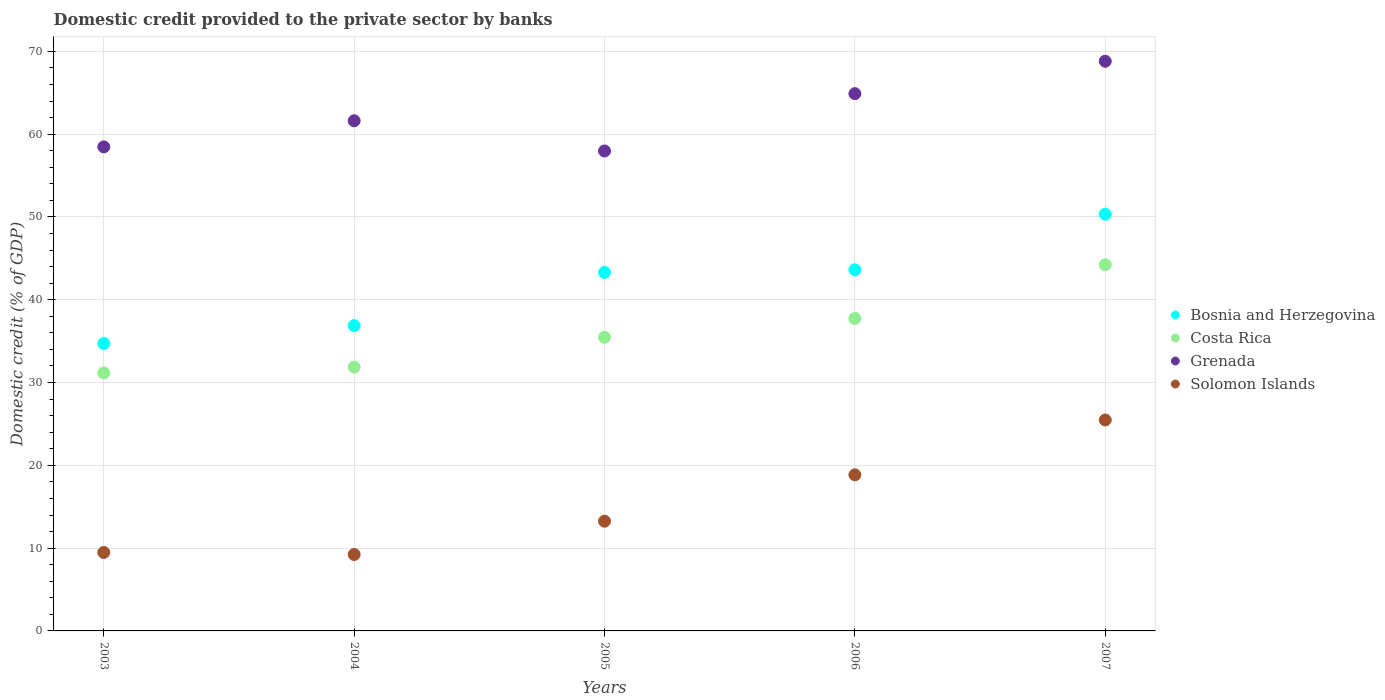How many different coloured dotlines are there?
Offer a terse response. 4. Is the number of dotlines equal to the number of legend labels?
Offer a terse response. Yes. What is the domestic credit provided to the private sector by banks in Costa Rica in 2003?
Give a very brief answer. 31.15. Across all years, what is the maximum domestic credit provided to the private sector by banks in Grenada?
Your answer should be compact. 68.81. Across all years, what is the minimum domestic credit provided to the private sector by banks in Solomon Islands?
Make the answer very short. 9.23. In which year was the domestic credit provided to the private sector by banks in Grenada maximum?
Your answer should be compact. 2007. What is the total domestic credit provided to the private sector by banks in Bosnia and Herzegovina in the graph?
Provide a succinct answer. 208.86. What is the difference between the domestic credit provided to the private sector by banks in Costa Rica in 2004 and that in 2006?
Ensure brevity in your answer.  -5.88. What is the difference between the domestic credit provided to the private sector by banks in Grenada in 2004 and the domestic credit provided to the private sector by banks in Costa Rica in 2005?
Make the answer very short. 26.14. What is the average domestic credit provided to the private sector by banks in Solomon Islands per year?
Provide a short and direct response. 15.26. In the year 2007, what is the difference between the domestic credit provided to the private sector by banks in Bosnia and Herzegovina and domestic credit provided to the private sector by banks in Costa Rica?
Provide a short and direct response. 6.12. What is the ratio of the domestic credit provided to the private sector by banks in Costa Rica in 2003 to that in 2007?
Your answer should be compact. 0.7. Is the domestic credit provided to the private sector by banks in Grenada in 2006 less than that in 2007?
Ensure brevity in your answer.  Yes. Is the difference between the domestic credit provided to the private sector by banks in Bosnia and Herzegovina in 2006 and 2007 greater than the difference between the domestic credit provided to the private sector by banks in Costa Rica in 2006 and 2007?
Your answer should be compact. No. What is the difference between the highest and the second highest domestic credit provided to the private sector by banks in Bosnia and Herzegovina?
Offer a terse response. 6.72. What is the difference between the highest and the lowest domestic credit provided to the private sector by banks in Grenada?
Provide a short and direct response. 10.84. Is it the case that in every year, the sum of the domestic credit provided to the private sector by banks in Costa Rica and domestic credit provided to the private sector by banks in Solomon Islands  is greater than the sum of domestic credit provided to the private sector by banks in Grenada and domestic credit provided to the private sector by banks in Bosnia and Herzegovina?
Your answer should be very brief. No. How many years are there in the graph?
Make the answer very short. 5. Are the values on the major ticks of Y-axis written in scientific E-notation?
Make the answer very short. No. Does the graph contain any zero values?
Your answer should be compact. No. What is the title of the graph?
Your response must be concise. Domestic credit provided to the private sector by banks. What is the label or title of the X-axis?
Provide a succinct answer. Years. What is the label or title of the Y-axis?
Offer a terse response. Domestic credit (% of GDP). What is the Domestic credit (% of GDP) in Bosnia and Herzegovina in 2003?
Keep it short and to the point. 34.72. What is the Domestic credit (% of GDP) in Costa Rica in 2003?
Your answer should be very brief. 31.15. What is the Domestic credit (% of GDP) in Grenada in 2003?
Keep it short and to the point. 58.46. What is the Domestic credit (% of GDP) in Solomon Islands in 2003?
Make the answer very short. 9.48. What is the Domestic credit (% of GDP) of Bosnia and Herzegovina in 2004?
Your answer should be very brief. 36.88. What is the Domestic credit (% of GDP) of Costa Rica in 2004?
Your answer should be very brief. 31.87. What is the Domestic credit (% of GDP) in Grenada in 2004?
Your response must be concise. 61.62. What is the Domestic credit (% of GDP) in Solomon Islands in 2004?
Your answer should be very brief. 9.23. What is the Domestic credit (% of GDP) of Bosnia and Herzegovina in 2005?
Provide a short and direct response. 43.31. What is the Domestic credit (% of GDP) in Costa Rica in 2005?
Make the answer very short. 35.48. What is the Domestic credit (% of GDP) in Grenada in 2005?
Make the answer very short. 57.97. What is the Domestic credit (% of GDP) of Solomon Islands in 2005?
Make the answer very short. 13.25. What is the Domestic credit (% of GDP) in Bosnia and Herzegovina in 2006?
Offer a terse response. 43.62. What is the Domestic credit (% of GDP) of Costa Rica in 2006?
Ensure brevity in your answer.  37.75. What is the Domestic credit (% of GDP) in Grenada in 2006?
Provide a succinct answer. 64.89. What is the Domestic credit (% of GDP) in Solomon Islands in 2006?
Your answer should be very brief. 18.85. What is the Domestic credit (% of GDP) of Bosnia and Herzegovina in 2007?
Provide a succinct answer. 50.34. What is the Domestic credit (% of GDP) in Costa Rica in 2007?
Your response must be concise. 44.22. What is the Domestic credit (% of GDP) in Grenada in 2007?
Offer a terse response. 68.81. What is the Domestic credit (% of GDP) of Solomon Islands in 2007?
Ensure brevity in your answer.  25.48. Across all years, what is the maximum Domestic credit (% of GDP) of Bosnia and Herzegovina?
Give a very brief answer. 50.34. Across all years, what is the maximum Domestic credit (% of GDP) of Costa Rica?
Provide a short and direct response. 44.22. Across all years, what is the maximum Domestic credit (% of GDP) in Grenada?
Make the answer very short. 68.81. Across all years, what is the maximum Domestic credit (% of GDP) in Solomon Islands?
Offer a very short reply. 25.48. Across all years, what is the minimum Domestic credit (% of GDP) in Bosnia and Herzegovina?
Provide a succinct answer. 34.72. Across all years, what is the minimum Domestic credit (% of GDP) of Costa Rica?
Provide a short and direct response. 31.15. Across all years, what is the minimum Domestic credit (% of GDP) in Grenada?
Your response must be concise. 57.97. Across all years, what is the minimum Domestic credit (% of GDP) in Solomon Islands?
Keep it short and to the point. 9.23. What is the total Domestic credit (% of GDP) of Bosnia and Herzegovina in the graph?
Offer a very short reply. 208.86. What is the total Domestic credit (% of GDP) in Costa Rica in the graph?
Make the answer very short. 180.46. What is the total Domestic credit (% of GDP) in Grenada in the graph?
Offer a terse response. 311.75. What is the total Domestic credit (% of GDP) of Solomon Islands in the graph?
Provide a succinct answer. 76.29. What is the difference between the Domestic credit (% of GDP) of Bosnia and Herzegovina in 2003 and that in 2004?
Offer a very short reply. -2.16. What is the difference between the Domestic credit (% of GDP) of Costa Rica in 2003 and that in 2004?
Your response must be concise. -0.72. What is the difference between the Domestic credit (% of GDP) in Grenada in 2003 and that in 2004?
Your answer should be very brief. -3.15. What is the difference between the Domestic credit (% of GDP) in Solomon Islands in 2003 and that in 2004?
Make the answer very short. 0.25. What is the difference between the Domestic credit (% of GDP) in Bosnia and Herzegovina in 2003 and that in 2005?
Keep it short and to the point. -8.59. What is the difference between the Domestic credit (% of GDP) in Costa Rica in 2003 and that in 2005?
Your answer should be very brief. -4.33. What is the difference between the Domestic credit (% of GDP) in Grenada in 2003 and that in 2005?
Give a very brief answer. 0.5. What is the difference between the Domestic credit (% of GDP) of Solomon Islands in 2003 and that in 2005?
Your response must be concise. -3.78. What is the difference between the Domestic credit (% of GDP) in Bosnia and Herzegovina in 2003 and that in 2006?
Provide a succinct answer. -8.9. What is the difference between the Domestic credit (% of GDP) of Costa Rica in 2003 and that in 2006?
Your answer should be compact. -6.6. What is the difference between the Domestic credit (% of GDP) of Grenada in 2003 and that in 2006?
Keep it short and to the point. -6.43. What is the difference between the Domestic credit (% of GDP) of Solomon Islands in 2003 and that in 2006?
Provide a short and direct response. -9.37. What is the difference between the Domestic credit (% of GDP) in Bosnia and Herzegovina in 2003 and that in 2007?
Give a very brief answer. -15.62. What is the difference between the Domestic credit (% of GDP) of Costa Rica in 2003 and that in 2007?
Keep it short and to the point. -13.07. What is the difference between the Domestic credit (% of GDP) of Grenada in 2003 and that in 2007?
Offer a terse response. -10.34. What is the difference between the Domestic credit (% of GDP) of Solomon Islands in 2003 and that in 2007?
Give a very brief answer. -16. What is the difference between the Domestic credit (% of GDP) of Bosnia and Herzegovina in 2004 and that in 2005?
Give a very brief answer. -6.43. What is the difference between the Domestic credit (% of GDP) of Costa Rica in 2004 and that in 2005?
Offer a terse response. -3.61. What is the difference between the Domestic credit (% of GDP) in Grenada in 2004 and that in 2005?
Give a very brief answer. 3.65. What is the difference between the Domestic credit (% of GDP) in Solomon Islands in 2004 and that in 2005?
Your answer should be very brief. -4.02. What is the difference between the Domestic credit (% of GDP) of Bosnia and Herzegovina in 2004 and that in 2006?
Your answer should be very brief. -6.74. What is the difference between the Domestic credit (% of GDP) of Costa Rica in 2004 and that in 2006?
Your response must be concise. -5.88. What is the difference between the Domestic credit (% of GDP) in Grenada in 2004 and that in 2006?
Provide a succinct answer. -3.28. What is the difference between the Domestic credit (% of GDP) of Solomon Islands in 2004 and that in 2006?
Your response must be concise. -9.62. What is the difference between the Domestic credit (% of GDP) of Bosnia and Herzegovina in 2004 and that in 2007?
Your answer should be compact. -13.46. What is the difference between the Domestic credit (% of GDP) of Costa Rica in 2004 and that in 2007?
Your response must be concise. -12.35. What is the difference between the Domestic credit (% of GDP) in Grenada in 2004 and that in 2007?
Keep it short and to the point. -7.19. What is the difference between the Domestic credit (% of GDP) in Solomon Islands in 2004 and that in 2007?
Your answer should be very brief. -16.25. What is the difference between the Domestic credit (% of GDP) in Bosnia and Herzegovina in 2005 and that in 2006?
Ensure brevity in your answer.  -0.31. What is the difference between the Domestic credit (% of GDP) of Costa Rica in 2005 and that in 2006?
Your answer should be very brief. -2.27. What is the difference between the Domestic credit (% of GDP) in Grenada in 2005 and that in 2006?
Your response must be concise. -6.93. What is the difference between the Domestic credit (% of GDP) in Solomon Islands in 2005 and that in 2006?
Your answer should be compact. -5.6. What is the difference between the Domestic credit (% of GDP) of Bosnia and Herzegovina in 2005 and that in 2007?
Your answer should be very brief. -7.03. What is the difference between the Domestic credit (% of GDP) of Costa Rica in 2005 and that in 2007?
Offer a terse response. -8.74. What is the difference between the Domestic credit (% of GDP) of Grenada in 2005 and that in 2007?
Your response must be concise. -10.84. What is the difference between the Domestic credit (% of GDP) in Solomon Islands in 2005 and that in 2007?
Your answer should be compact. -12.22. What is the difference between the Domestic credit (% of GDP) in Bosnia and Herzegovina in 2006 and that in 2007?
Provide a short and direct response. -6.72. What is the difference between the Domestic credit (% of GDP) of Costa Rica in 2006 and that in 2007?
Your response must be concise. -6.48. What is the difference between the Domestic credit (% of GDP) of Grenada in 2006 and that in 2007?
Ensure brevity in your answer.  -3.91. What is the difference between the Domestic credit (% of GDP) in Solomon Islands in 2006 and that in 2007?
Offer a terse response. -6.63. What is the difference between the Domestic credit (% of GDP) of Bosnia and Herzegovina in 2003 and the Domestic credit (% of GDP) of Costa Rica in 2004?
Your answer should be very brief. 2.85. What is the difference between the Domestic credit (% of GDP) in Bosnia and Herzegovina in 2003 and the Domestic credit (% of GDP) in Grenada in 2004?
Keep it short and to the point. -26.9. What is the difference between the Domestic credit (% of GDP) of Bosnia and Herzegovina in 2003 and the Domestic credit (% of GDP) of Solomon Islands in 2004?
Offer a very short reply. 25.49. What is the difference between the Domestic credit (% of GDP) in Costa Rica in 2003 and the Domestic credit (% of GDP) in Grenada in 2004?
Keep it short and to the point. -30.47. What is the difference between the Domestic credit (% of GDP) in Costa Rica in 2003 and the Domestic credit (% of GDP) in Solomon Islands in 2004?
Ensure brevity in your answer.  21.92. What is the difference between the Domestic credit (% of GDP) of Grenada in 2003 and the Domestic credit (% of GDP) of Solomon Islands in 2004?
Make the answer very short. 49.23. What is the difference between the Domestic credit (% of GDP) in Bosnia and Herzegovina in 2003 and the Domestic credit (% of GDP) in Costa Rica in 2005?
Your answer should be very brief. -0.76. What is the difference between the Domestic credit (% of GDP) of Bosnia and Herzegovina in 2003 and the Domestic credit (% of GDP) of Grenada in 2005?
Offer a very short reply. -23.25. What is the difference between the Domestic credit (% of GDP) in Bosnia and Herzegovina in 2003 and the Domestic credit (% of GDP) in Solomon Islands in 2005?
Offer a terse response. 21.46. What is the difference between the Domestic credit (% of GDP) in Costa Rica in 2003 and the Domestic credit (% of GDP) in Grenada in 2005?
Keep it short and to the point. -26.82. What is the difference between the Domestic credit (% of GDP) of Costa Rica in 2003 and the Domestic credit (% of GDP) of Solomon Islands in 2005?
Give a very brief answer. 17.89. What is the difference between the Domestic credit (% of GDP) of Grenada in 2003 and the Domestic credit (% of GDP) of Solomon Islands in 2005?
Keep it short and to the point. 45.21. What is the difference between the Domestic credit (% of GDP) of Bosnia and Herzegovina in 2003 and the Domestic credit (% of GDP) of Costa Rica in 2006?
Provide a short and direct response. -3.03. What is the difference between the Domestic credit (% of GDP) in Bosnia and Herzegovina in 2003 and the Domestic credit (% of GDP) in Grenada in 2006?
Make the answer very short. -30.18. What is the difference between the Domestic credit (% of GDP) of Bosnia and Herzegovina in 2003 and the Domestic credit (% of GDP) of Solomon Islands in 2006?
Make the answer very short. 15.87. What is the difference between the Domestic credit (% of GDP) in Costa Rica in 2003 and the Domestic credit (% of GDP) in Grenada in 2006?
Your response must be concise. -33.74. What is the difference between the Domestic credit (% of GDP) of Costa Rica in 2003 and the Domestic credit (% of GDP) of Solomon Islands in 2006?
Offer a terse response. 12.3. What is the difference between the Domestic credit (% of GDP) in Grenada in 2003 and the Domestic credit (% of GDP) in Solomon Islands in 2006?
Your answer should be compact. 39.61. What is the difference between the Domestic credit (% of GDP) of Bosnia and Herzegovina in 2003 and the Domestic credit (% of GDP) of Costa Rica in 2007?
Keep it short and to the point. -9.51. What is the difference between the Domestic credit (% of GDP) of Bosnia and Herzegovina in 2003 and the Domestic credit (% of GDP) of Grenada in 2007?
Keep it short and to the point. -34.09. What is the difference between the Domestic credit (% of GDP) of Bosnia and Herzegovina in 2003 and the Domestic credit (% of GDP) of Solomon Islands in 2007?
Your answer should be compact. 9.24. What is the difference between the Domestic credit (% of GDP) in Costa Rica in 2003 and the Domestic credit (% of GDP) in Grenada in 2007?
Offer a very short reply. -37.66. What is the difference between the Domestic credit (% of GDP) in Costa Rica in 2003 and the Domestic credit (% of GDP) in Solomon Islands in 2007?
Your response must be concise. 5.67. What is the difference between the Domestic credit (% of GDP) of Grenada in 2003 and the Domestic credit (% of GDP) of Solomon Islands in 2007?
Provide a succinct answer. 32.99. What is the difference between the Domestic credit (% of GDP) of Bosnia and Herzegovina in 2004 and the Domestic credit (% of GDP) of Costa Rica in 2005?
Provide a short and direct response. 1.4. What is the difference between the Domestic credit (% of GDP) in Bosnia and Herzegovina in 2004 and the Domestic credit (% of GDP) in Grenada in 2005?
Offer a very short reply. -21.09. What is the difference between the Domestic credit (% of GDP) of Bosnia and Herzegovina in 2004 and the Domestic credit (% of GDP) of Solomon Islands in 2005?
Your answer should be very brief. 23.62. What is the difference between the Domestic credit (% of GDP) of Costa Rica in 2004 and the Domestic credit (% of GDP) of Grenada in 2005?
Your response must be concise. -26.1. What is the difference between the Domestic credit (% of GDP) in Costa Rica in 2004 and the Domestic credit (% of GDP) in Solomon Islands in 2005?
Offer a very short reply. 18.61. What is the difference between the Domestic credit (% of GDP) in Grenada in 2004 and the Domestic credit (% of GDP) in Solomon Islands in 2005?
Ensure brevity in your answer.  48.36. What is the difference between the Domestic credit (% of GDP) of Bosnia and Herzegovina in 2004 and the Domestic credit (% of GDP) of Costa Rica in 2006?
Give a very brief answer. -0.87. What is the difference between the Domestic credit (% of GDP) of Bosnia and Herzegovina in 2004 and the Domestic credit (% of GDP) of Grenada in 2006?
Provide a succinct answer. -28.02. What is the difference between the Domestic credit (% of GDP) of Bosnia and Herzegovina in 2004 and the Domestic credit (% of GDP) of Solomon Islands in 2006?
Keep it short and to the point. 18.03. What is the difference between the Domestic credit (% of GDP) in Costa Rica in 2004 and the Domestic credit (% of GDP) in Grenada in 2006?
Ensure brevity in your answer.  -33.02. What is the difference between the Domestic credit (% of GDP) of Costa Rica in 2004 and the Domestic credit (% of GDP) of Solomon Islands in 2006?
Your answer should be compact. 13.02. What is the difference between the Domestic credit (% of GDP) of Grenada in 2004 and the Domestic credit (% of GDP) of Solomon Islands in 2006?
Your response must be concise. 42.77. What is the difference between the Domestic credit (% of GDP) in Bosnia and Herzegovina in 2004 and the Domestic credit (% of GDP) in Costa Rica in 2007?
Give a very brief answer. -7.35. What is the difference between the Domestic credit (% of GDP) in Bosnia and Herzegovina in 2004 and the Domestic credit (% of GDP) in Grenada in 2007?
Your answer should be compact. -31.93. What is the difference between the Domestic credit (% of GDP) in Bosnia and Herzegovina in 2004 and the Domestic credit (% of GDP) in Solomon Islands in 2007?
Give a very brief answer. 11.4. What is the difference between the Domestic credit (% of GDP) in Costa Rica in 2004 and the Domestic credit (% of GDP) in Grenada in 2007?
Provide a short and direct response. -36.94. What is the difference between the Domestic credit (% of GDP) of Costa Rica in 2004 and the Domestic credit (% of GDP) of Solomon Islands in 2007?
Your answer should be compact. 6.39. What is the difference between the Domestic credit (% of GDP) in Grenada in 2004 and the Domestic credit (% of GDP) in Solomon Islands in 2007?
Keep it short and to the point. 36.14. What is the difference between the Domestic credit (% of GDP) of Bosnia and Herzegovina in 2005 and the Domestic credit (% of GDP) of Costa Rica in 2006?
Your response must be concise. 5.56. What is the difference between the Domestic credit (% of GDP) in Bosnia and Herzegovina in 2005 and the Domestic credit (% of GDP) in Grenada in 2006?
Your response must be concise. -21.59. What is the difference between the Domestic credit (% of GDP) in Bosnia and Herzegovina in 2005 and the Domestic credit (% of GDP) in Solomon Islands in 2006?
Your answer should be compact. 24.45. What is the difference between the Domestic credit (% of GDP) of Costa Rica in 2005 and the Domestic credit (% of GDP) of Grenada in 2006?
Your answer should be very brief. -29.41. What is the difference between the Domestic credit (% of GDP) in Costa Rica in 2005 and the Domestic credit (% of GDP) in Solomon Islands in 2006?
Your answer should be very brief. 16.63. What is the difference between the Domestic credit (% of GDP) of Grenada in 2005 and the Domestic credit (% of GDP) of Solomon Islands in 2006?
Provide a succinct answer. 39.12. What is the difference between the Domestic credit (% of GDP) in Bosnia and Herzegovina in 2005 and the Domestic credit (% of GDP) in Costa Rica in 2007?
Make the answer very short. -0.92. What is the difference between the Domestic credit (% of GDP) of Bosnia and Herzegovina in 2005 and the Domestic credit (% of GDP) of Grenada in 2007?
Provide a succinct answer. -25.5. What is the difference between the Domestic credit (% of GDP) of Bosnia and Herzegovina in 2005 and the Domestic credit (% of GDP) of Solomon Islands in 2007?
Make the answer very short. 17.83. What is the difference between the Domestic credit (% of GDP) of Costa Rica in 2005 and the Domestic credit (% of GDP) of Grenada in 2007?
Provide a short and direct response. -33.33. What is the difference between the Domestic credit (% of GDP) of Costa Rica in 2005 and the Domestic credit (% of GDP) of Solomon Islands in 2007?
Offer a terse response. 10. What is the difference between the Domestic credit (% of GDP) in Grenada in 2005 and the Domestic credit (% of GDP) in Solomon Islands in 2007?
Offer a very short reply. 32.49. What is the difference between the Domestic credit (% of GDP) of Bosnia and Herzegovina in 2006 and the Domestic credit (% of GDP) of Costa Rica in 2007?
Keep it short and to the point. -0.6. What is the difference between the Domestic credit (% of GDP) of Bosnia and Herzegovina in 2006 and the Domestic credit (% of GDP) of Grenada in 2007?
Give a very brief answer. -25.19. What is the difference between the Domestic credit (% of GDP) of Bosnia and Herzegovina in 2006 and the Domestic credit (% of GDP) of Solomon Islands in 2007?
Offer a very short reply. 18.14. What is the difference between the Domestic credit (% of GDP) of Costa Rica in 2006 and the Domestic credit (% of GDP) of Grenada in 2007?
Offer a terse response. -31.06. What is the difference between the Domestic credit (% of GDP) of Costa Rica in 2006 and the Domestic credit (% of GDP) of Solomon Islands in 2007?
Your answer should be compact. 12.27. What is the difference between the Domestic credit (% of GDP) of Grenada in 2006 and the Domestic credit (% of GDP) of Solomon Islands in 2007?
Make the answer very short. 39.42. What is the average Domestic credit (% of GDP) of Bosnia and Herzegovina per year?
Your answer should be compact. 41.77. What is the average Domestic credit (% of GDP) of Costa Rica per year?
Provide a succinct answer. 36.09. What is the average Domestic credit (% of GDP) in Grenada per year?
Offer a terse response. 62.35. What is the average Domestic credit (% of GDP) in Solomon Islands per year?
Offer a terse response. 15.26. In the year 2003, what is the difference between the Domestic credit (% of GDP) in Bosnia and Herzegovina and Domestic credit (% of GDP) in Costa Rica?
Offer a very short reply. 3.57. In the year 2003, what is the difference between the Domestic credit (% of GDP) in Bosnia and Herzegovina and Domestic credit (% of GDP) in Grenada?
Offer a very short reply. -23.75. In the year 2003, what is the difference between the Domestic credit (% of GDP) of Bosnia and Herzegovina and Domestic credit (% of GDP) of Solomon Islands?
Ensure brevity in your answer.  25.24. In the year 2003, what is the difference between the Domestic credit (% of GDP) of Costa Rica and Domestic credit (% of GDP) of Grenada?
Offer a very short reply. -27.32. In the year 2003, what is the difference between the Domestic credit (% of GDP) in Costa Rica and Domestic credit (% of GDP) in Solomon Islands?
Offer a very short reply. 21.67. In the year 2003, what is the difference between the Domestic credit (% of GDP) of Grenada and Domestic credit (% of GDP) of Solomon Islands?
Make the answer very short. 48.99. In the year 2004, what is the difference between the Domestic credit (% of GDP) of Bosnia and Herzegovina and Domestic credit (% of GDP) of Costa Rica?
Provide a succinct answer. 5.01. In the year 2004, what is the difference between the Domestic credit (% of GDP) of Bosnia and Herzegovina and Domestic credit (% of GDP) of Grenada?
Provide a succinct answer. -24.74. In the year 2004, what is the difference between the Domestic credit (% of GDP) in Bosnia and Herzegovina and Domestic credit (% of GDP) in Solomon Islands?
Make the answer very short. 27.65. In the year 2004, what is the difference between the Domestic credit (% of GDP) of Costa Rica and Domestic credit (% of GDP) of Grenada?
Keep it short and to the point. -29.75. In the year 2004, what is the difference between the Domestic credit (% of GDP) in Costa Rica and Domestic credit (% of GDP) in Solomon Islands?
Your answer should be very brief. 22.64. In the year 2004, what is the difference between the Domestic credit (% of GDP) in Grenada and Domestic credit (% of GDP) in Solomon Islands?
Ensure brevity in your answer.  52.39. In the year 2005, what is the difference between the Domestic credit (% of GDP) in Bosnia and Herzegovina and Domestic credit (% of GDP) in Costa Rica?
Your response must be concise. 7.83. In the year 2005, what is the difference between the Domestic credit (% of GDP) in Bosnia and Herzegovina and Domestic credit (% of GDP) in Grenada?
Keep it short and to the point. -14.66. In the year 2005, what is the difference between the Domestic credit (% of GDP) in Bosnia and Herzegovina and Domestic credit (% of GDP) in Solomon Islands?
Your answer should be very brief. 30.05. In the year 2005, what is the difference between the Domestic credit (% of GDP) in Costa Rica and Domestic credit (% of GDP) in Grenada?
Provide a short and direct response. -22.49. In the year 2005, what is the difference between the Domestic credit (% of GDP) of Costa Rica and Domestic credit (% of GDP) of Solomon Islands?
Your response must be concise. 22.22. In the year 2005, what is the difference between the Domestic credit (% of GDP) in Grenada and Domestic credit (% of GDP) in Solomon Islands?
Keep it short and to the point. 44.71. In the year 2006, what is the difference between the Domestic credit (% of GDP) in Bosnia and Herzegovina and Domestic credit (% of GDP) in Costa Rica?
Offer a very short reply. 5.87. In the year 2006, what is the difference between the Domestic credit (% of GDP) of Bosnia and Herzegovina and Domestic credit (% of GDP) of Grenada?
Keep it short and to the point. -21.27. In the year 2006, what is the difference between the Domestic credit (% of GDP) in Bosnia and Herzegovina and Domestic credit (% of GDP) in Solomon Islands?
Make the answer very short. 24.77. In the year 2006, what is the difference between the Domestic credit (% of GDP) of Costa Rica and Domestic credit (% of GDP) of Grenada?
Your answer should be very brief. -27.15. In the year 2006, what is the difference between the Domestic credit (% of GDP) in Costa Rica and Domestic credit (% of GDP) in Solomon Islands?
Ensure brevity in your answer.  18.89. In the year 2006, what is the difference between the Domestic credit (% of GDP) of Grenada and Domestic credit (% of GDP) of Solomon Islands?
Offer a terse response. 46.04. In the year 2007, what is the difference between the Domestic credit (% of GDP) of Bosnia and Herzegovina and Domestic credit (% of GDP) of Costa Rica?
Your answer should be compact. 6.12. In the year 2007, what is the difference between the Domestic credit (% of GDP) of Bosnia and Herzegovina and Domestic credit (% of GDP) of Grenada?
Your answer should be compact. -18.47. In the year 2007, what is the difference between the Domestic credit (% of GDP) in Bosnia and Herzegovina and Domestic credit (% of GDP) in Solomon Islands?
Keep it short and to the point. 24.86. In the year 2007, what is the difference between the Domestic credit (% of GDP) of Costa Rica and Domestic credit (% of GDP) of Grenada?
Your answer should be very brief. -24.59. In the year 2007, what is the difference between the Domestic credit (% of GDP) in Costa Rica and Domestic credit (% of GDP) in Solomon Islands?
Keep it short and to the point. 18.75. In the year 2007, what is the difference between the Domestic credit (% of GDP) in Grenada and Domestic credit (% of GDP) in Solomon Islands?
Your answer should be very brief. 43.33. What is the ratio of the Domestic credit (% of GDP) of Bosnia and Herzegovina in 2003 to that in 2004?
Offer a terse response. 0.94. What is the ratio of the Domestic credit (% of GDP) in Costa Rica in 2003 to that in 2004?
Your response must be concise. 0.98. What is the ratio of the Domestic credit (% of GDP) in Grenada in 2003 to that in 2004?
Offer a very short reply. 0.95. What is the ratio of the Domestic credit (% of GDP) in Solomon Islands in 2003 to that in 2004?
Your response must be concise. 1.03. What is the ratio of the Domestic credit (% of GDP) in Bosnia and Herzegovina in 2003 to that in 2005?
Your response must be concise. 0.8. What is the ratio of the Domestic credit (% of GDP) in Costa Rica in 2003 to that in 2005?
Your response must be concise. 0.88. What is the ratio of the Domestic credit (% of GDP) of Grenada in 2003 to that in 2005?
Ensure brevity in your answer.  1.01. What is the ratio of the Domestic credit (% of GDP) of Solomon Islands in 2003 to that in 2005?
Offer a very short reply. 0.71. What is the ratio of the Domestic credit (% of GDP) of Bosnia and Herzegovina in 2003 to that in 2006?
Offer a terse response. 0.8. What is the ratio of the Domestic credit (% of GDP) in Costa Rica in 2003 to that in 2006?
Your answer should be very brief. 0.83. What is the ratio of the Domestic credit (% of GDP) in Grenada in 2003 to that in 2006?
Your answer should be very brief. 0.9. What is the ratio of the Domestic credit (% of GDP) in Solomon Islands in 2003 to that in 2006?
Offer a very short reply. 0.5. What is the ratio of the Domestic credit (% of GDP) in Bosnia and Herzegovina in 2003 to that in 2007?
Your answer should be compact. 0.69. What is the ratio of the Domestic credit (% of GDP) in Costa Rica in 2003 to that in 2007?
Ensure brevity in your answer.  0.7. What is the ratio of the Domestic credit (% of GDP) of Grenada in 2003 to that in 2007?
Make the answer very short. 0.85. What is the ratio of the Domestic credit (% of GDP) in Solomon Islands in 2003 to that in 2007?
Make the answer very short. 0.37. What is the ratio of the Domestic credit (% of GDP) in Bosnia and Herzegovina in 2004 to that in 2005?
Your answer should be very brief. 0.85. What is the ratio of the Domestic credit (% of GDP) of Costa Rica in 2004 to that in 2005?
Your response must be concise. 0.9. What is the ratio of the Domestic credit (% of GDP) of Grenada in 2004 to that in 2005?
Keep it short and to the point. 1.06. What is the ratio of the Domestic credit (% of GDP) in Solomon Islands in 2004 to that in 2005?
Your response must be concise. 0.7. What is the ratio of the Domestic credit (% of GDP) of Bosnia and Herzegovina in 2004 to that in 2006?
Provide a succinct answer. 0.85. What is the ratio of the Domestic credit (% of GDP) in Costa Rica in 2004 to that in 2006?
Provide a succinct answer. 0.84. What is the ratio of the Domestic credit (% of GDP) of Grenada in 2004 to that in 2006?
Keep it short and to the point. 0.95. What is the ratio of the Domestic credit (% of GDP) in Solomon Islands in 2004 to that in 2006?
Make the answer very short. 0.49. What is the ratio of the Domestic credit (% of GDP) of Bosnia and Herzegovina in 2004 to that in 2007?
Provide a succinct answer. 0.73. What is the ratio of the Domestic credit (% of GDP) in Costa Rica in 2004 to that in 2007?
Ensure brevity in your answer.  0.72. What is the ratio of the Domestic credit (% of GDP) in Grenada in 2004 to that in 2007?
Keep it short and to the point. 0.9. What is the ratio of the Domestic credit (% of GDP) of Solomon Islands in 2004 to that in 2007?
Provide a succinct answer. 0.36. What is the ratio of the Domestic credit (% of GDP) of Bosnia and Herzegovina in 2005 to that in 2006?
Your response must be concise. 0.99. What is the ratio of the Domestic credit (% of GDP) in Costa Rica in 2005 to that in 2006?
Your answer should be very brief. 0.94. What is the ratio of the Domestic credit (% of GDP) of Grenada in 2005 to that in 2006?
Ensure brevity in your answer.  0.89. What is the ratio of the Domestic credit (% of GDP) of Solomon Islands in 2005 to that in 2006?
Provide a succinct answer. 0.7. What is the ratio of the Domestic credit (% of GDP) of Bosnia and Herzegovina in 2005 to that in 2007?
Your answer should be compact. 0.86. What is the ratio of the Domestic credit (% of GDP) in Costa Rica in 2005 to that in 2007?
Give a very brief answer. 0.8. What is the ratio of the Domestic credit (% of GDP) in Grenada in 2005 to that in 2007?
Make the answer very short. 0.84. What is the ratio of the Domestic credit (% of GDP) of Solomon Islands in 2005 to that in 2007?
Keep it short and to the point. 0.52. What is the ratio of the Domestic credit (% of GDP) of Bosnia and Herzegovina in 2006 to that in 2007?
Provide a succinct answer. 0.87. What is the ratio of the Domestic credit (% of GDP) of Costa Rica in 2006 to that in 2007?
Give a very brief answer. 0.85. What is the ratio of the Domestic credit (% of GDP) in Grenada in 2006 to that in 2007?
Ensure brevity in your answer.  0.94. What is the ratio of the Domestic credit (% of GDP) of Solomon Islands in 2006 to that in 2007?
Provide a short and direct response. 0.74. What is the difference between the highest and the second highest Domestic credit (% of GDP) of Bosnia and Herzegovina?
Your answer should be compact. 6.72. What is the difference between the highest and the second highest Domestic credit (% of GDP) of Costa Rica?
Keep it short and to the point. 6.48. What is the difference between the highest and the second highest Domestic credit (% of GDP) of Grenada?
Provide a short and direct response. 3.91. What is the difference between the highest and the second highest Domestic credit (% of GDP) of Solomon Islands?
Your answer should be compact. 6.63. What is the difference between the highest and the lowest Domestic credit (% of GDP) of Bosnia and Herzegovina?
Provide a succinct answer. 15.62. What is the difference between the highest and the lowest Domestic credit (% of GDP) of Costa Rica?
Your response must be concise. 13.07. What is the difference between the highest and the lowest Domestic credit (% of GDP) of Grenada?
Provide a succinct answer. 10.84. What is the difference between the highest and the lowest Domestic credit (% of GDP) in Solomon Islands?
Your response must be concise. 16.25. 